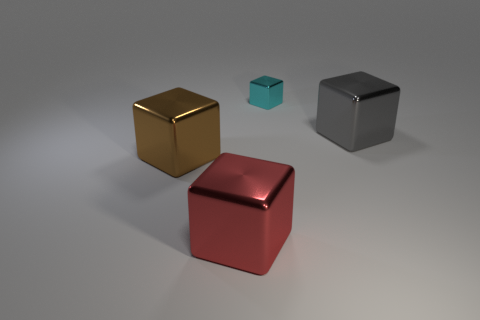How many other objects are there of the same material as the brown block?
Your answer should be compact. 3. What is the size of the block that is to the left of the big thing that is in front of the large brown thing?
Give a very brief answer. Large. Are there more metallic objects in front of the brown object than small green rubber blocks?
Offer a terse response. Yes. There is a cube that is to the right of the cyan shiny object; is its size the same as the brown metal cube?
Provide a succinct answer. Yes. What color is the shiny cube that is to the right of the big red metallic thing and in front of the small thing?
Your answer should be compact. Gray. The gray thing that is the same size as the red metallic thing is what shape?
Give a very brief answer. Cube. Are there an equal number of small cyan metallic blocks that are in front of the gray cube and small purple shiny blocks?
Offer a terse response. Yes. What size is the shiny object that is both left of the gray thing and right of the red block?
Give a very brief answer. Small. What is the color of the tiny block that is the same material as the brown thing?
Provide a short and direct response. Cyan. What number of other large blocks have the same material as the big gray block?
Ensure brevity in your answer.  2. 